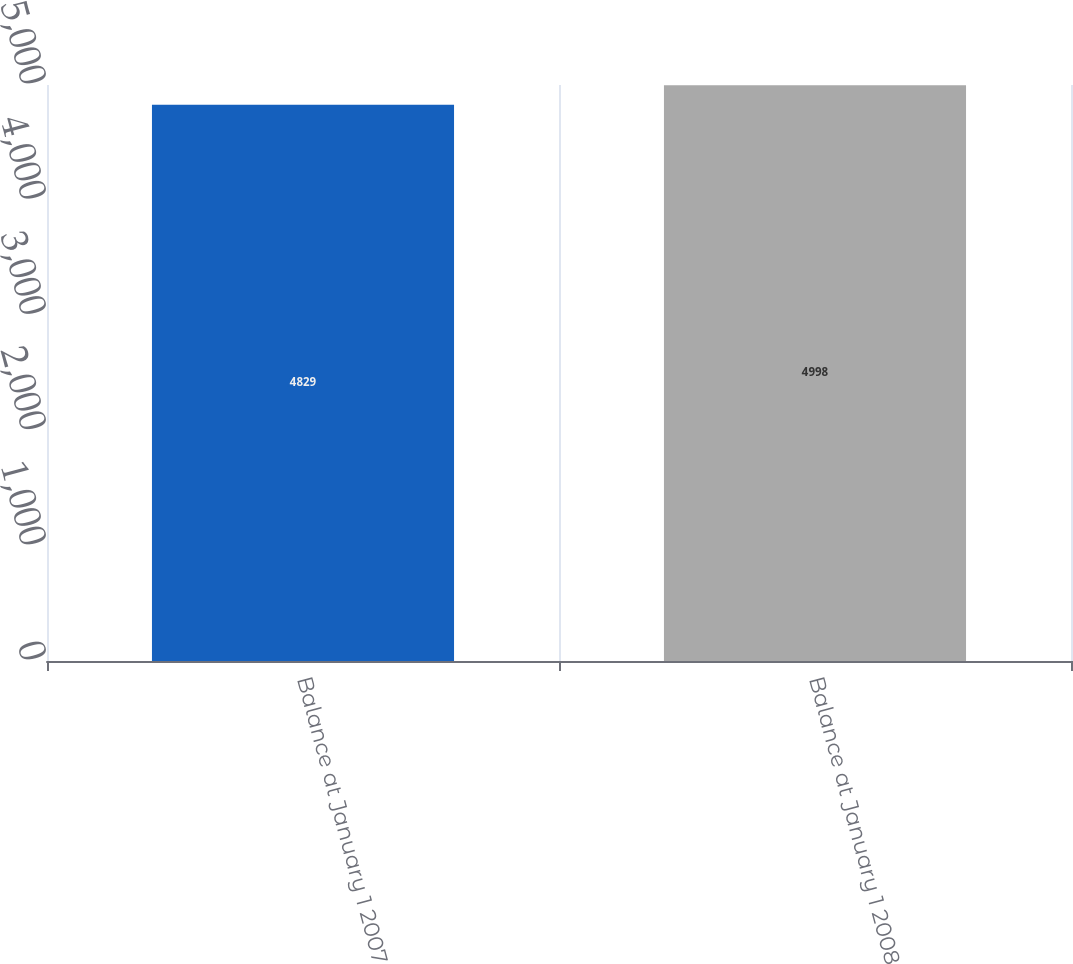Convert chart. <chart><loc_0><loc_0><loc_500><loc_500><bar_chart><fcel>Balance at January 1 2007<fcel>Balance at January 1 2008<nl><fcel>4829<fcel>4998<nl></chart> 